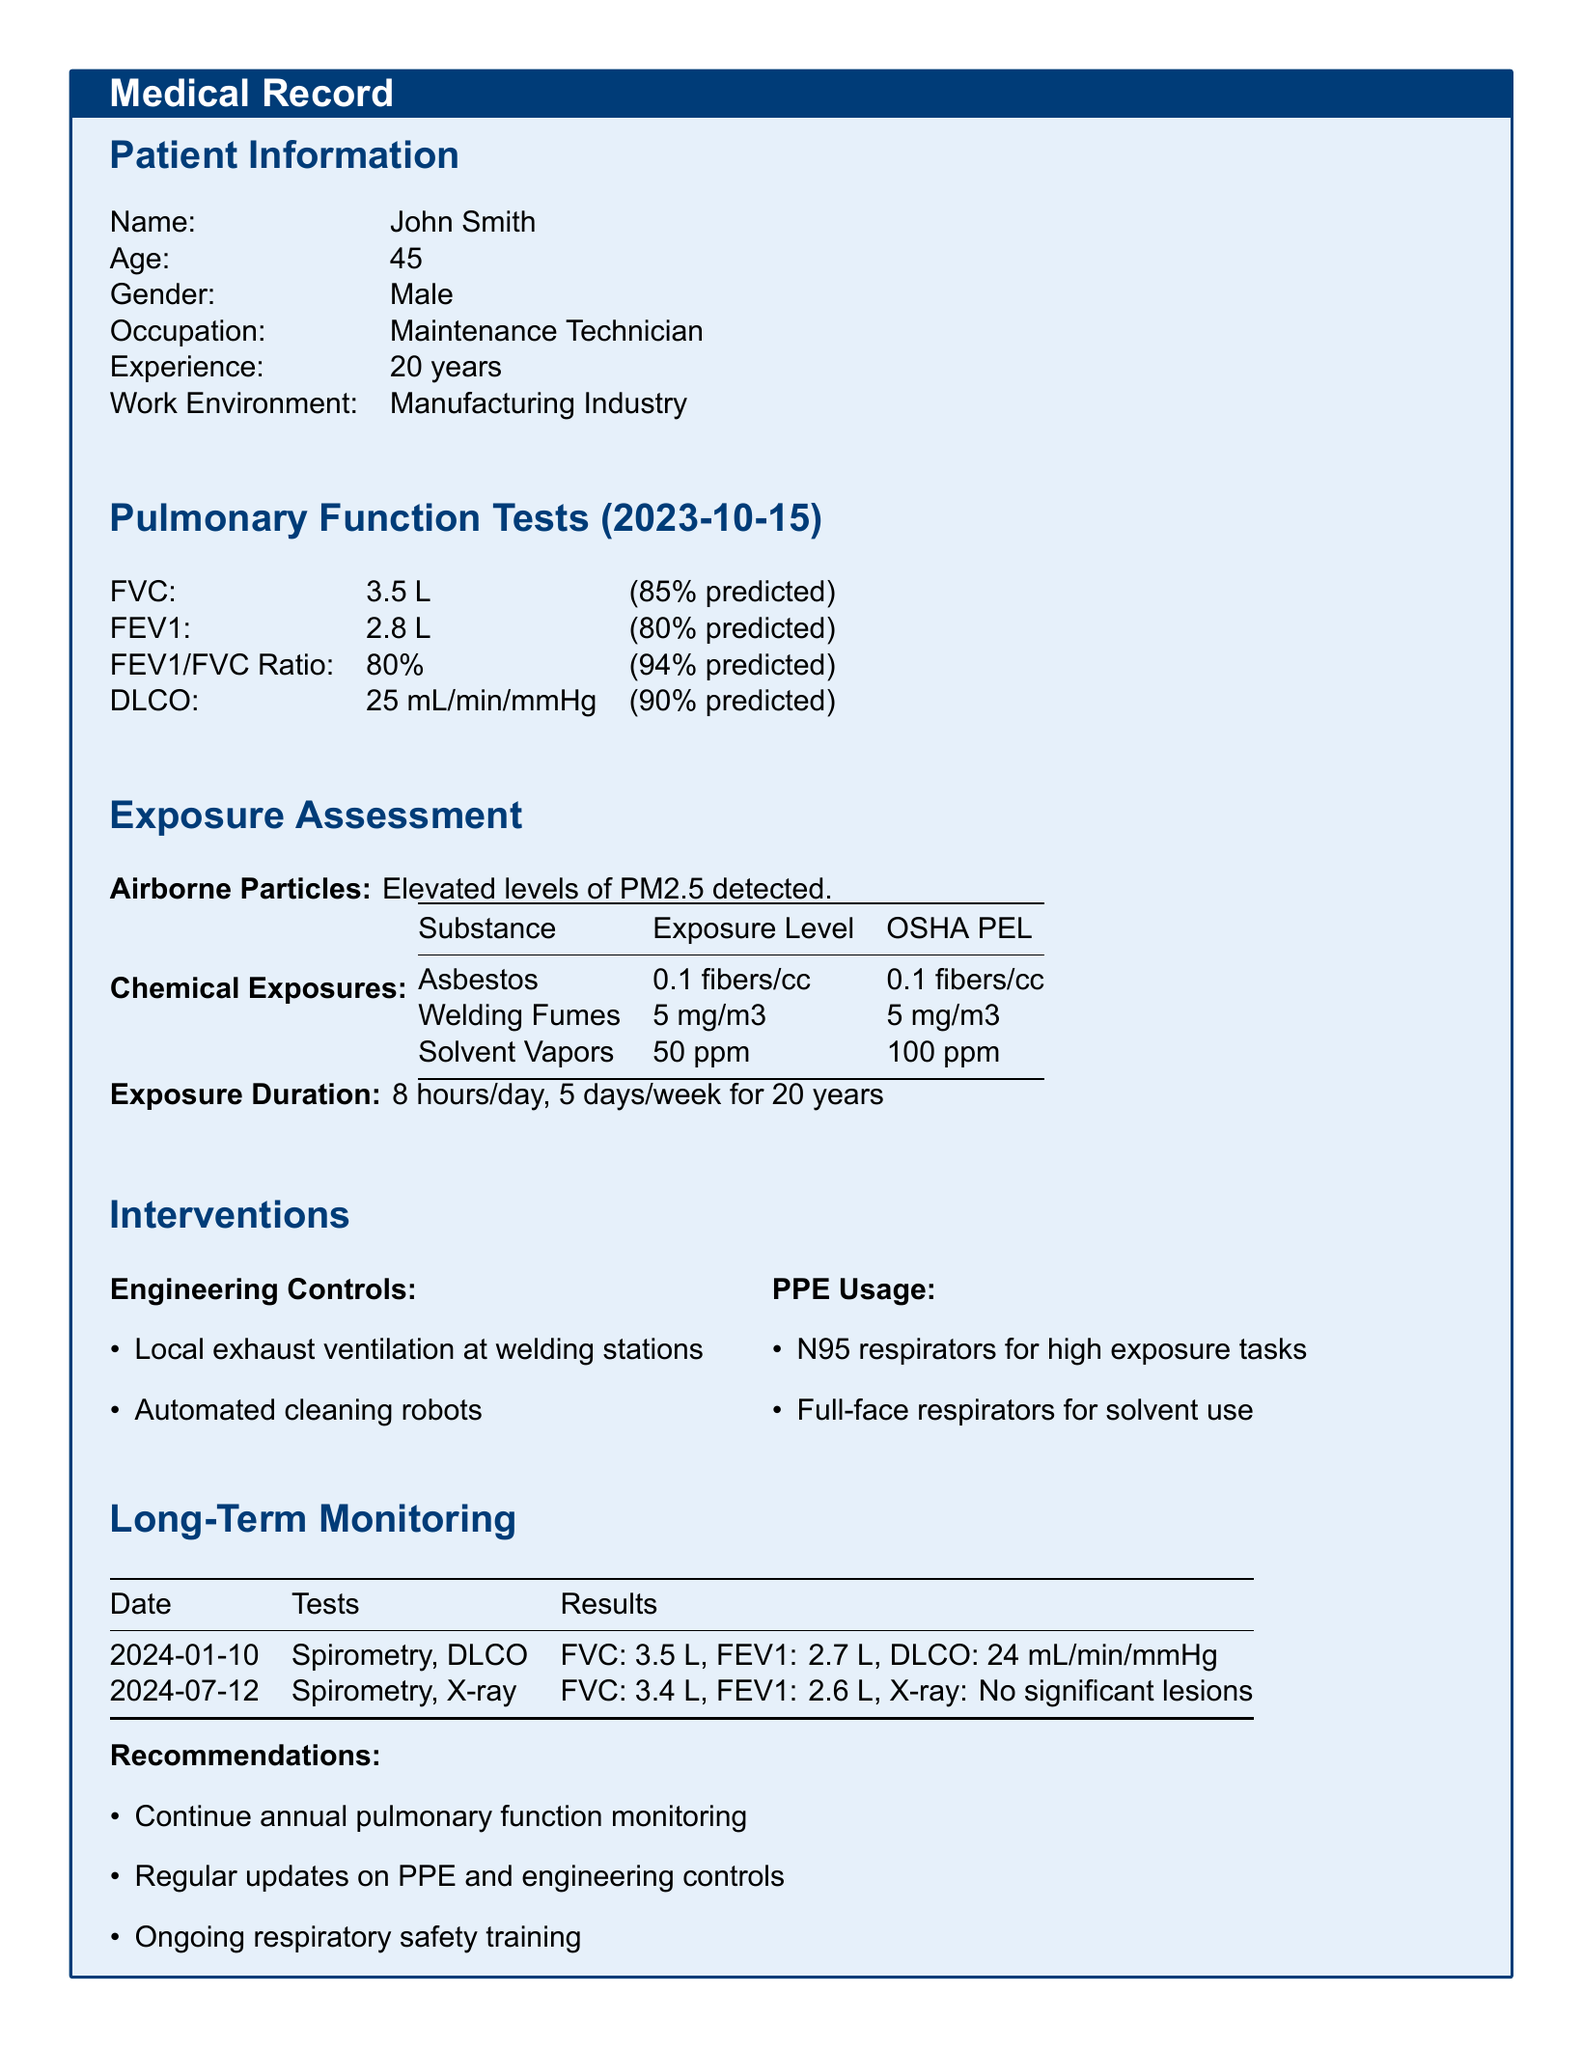What is the patient's name? The patient's name is listed in the Patient Information section as John Smith.
Answer: John Smith What is the patient's age? The age of the patient is mentioned in the Patient Information section as 45.
Answer: 45 What is the FEV1 result? The FEV1 result is found in the Pulmonary Function Tests section, indicated as 2.8 L.
Answer: 2.8 L What is the exposure level for asbestos? The exposure level for asbestos is provided in the Exposure Assessment section as 0.1 fibers/cc.
Answer: 0.1 fibers/cc How long has the patient been exposed? The Exposure Duration section states that the patient's exposure duration is 8 hours/day for 20 years.
Answer: 20 years What recommendations are made for the patient? Recommendations are listed at the end of the document, including annual pulmonary function monitoring and ongoing respiratory safety training.
Answer: Continue annual pulmonary function monitoring What type of respirators is used for high exposure tasks? The PPE Usage section mentions that N95 respirators are used for high exposure tasks.
Answer: N95 respirators What pulmonary function test was conducted on 2024-01-10? The Long-Term Monitoring section specifies that spirometry and DLCO tests were conducted on that date.
Answer: Spirometry, DLCO What is the predicted percentage for FVC? The predicted percentage for FVC is noted in the Pulmonary Function Tests section as 85%.
Answer: 85% 